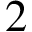Convert formula to latex. <formula><loc_0><loc_0><loc_500><loc_500>2</formula> 